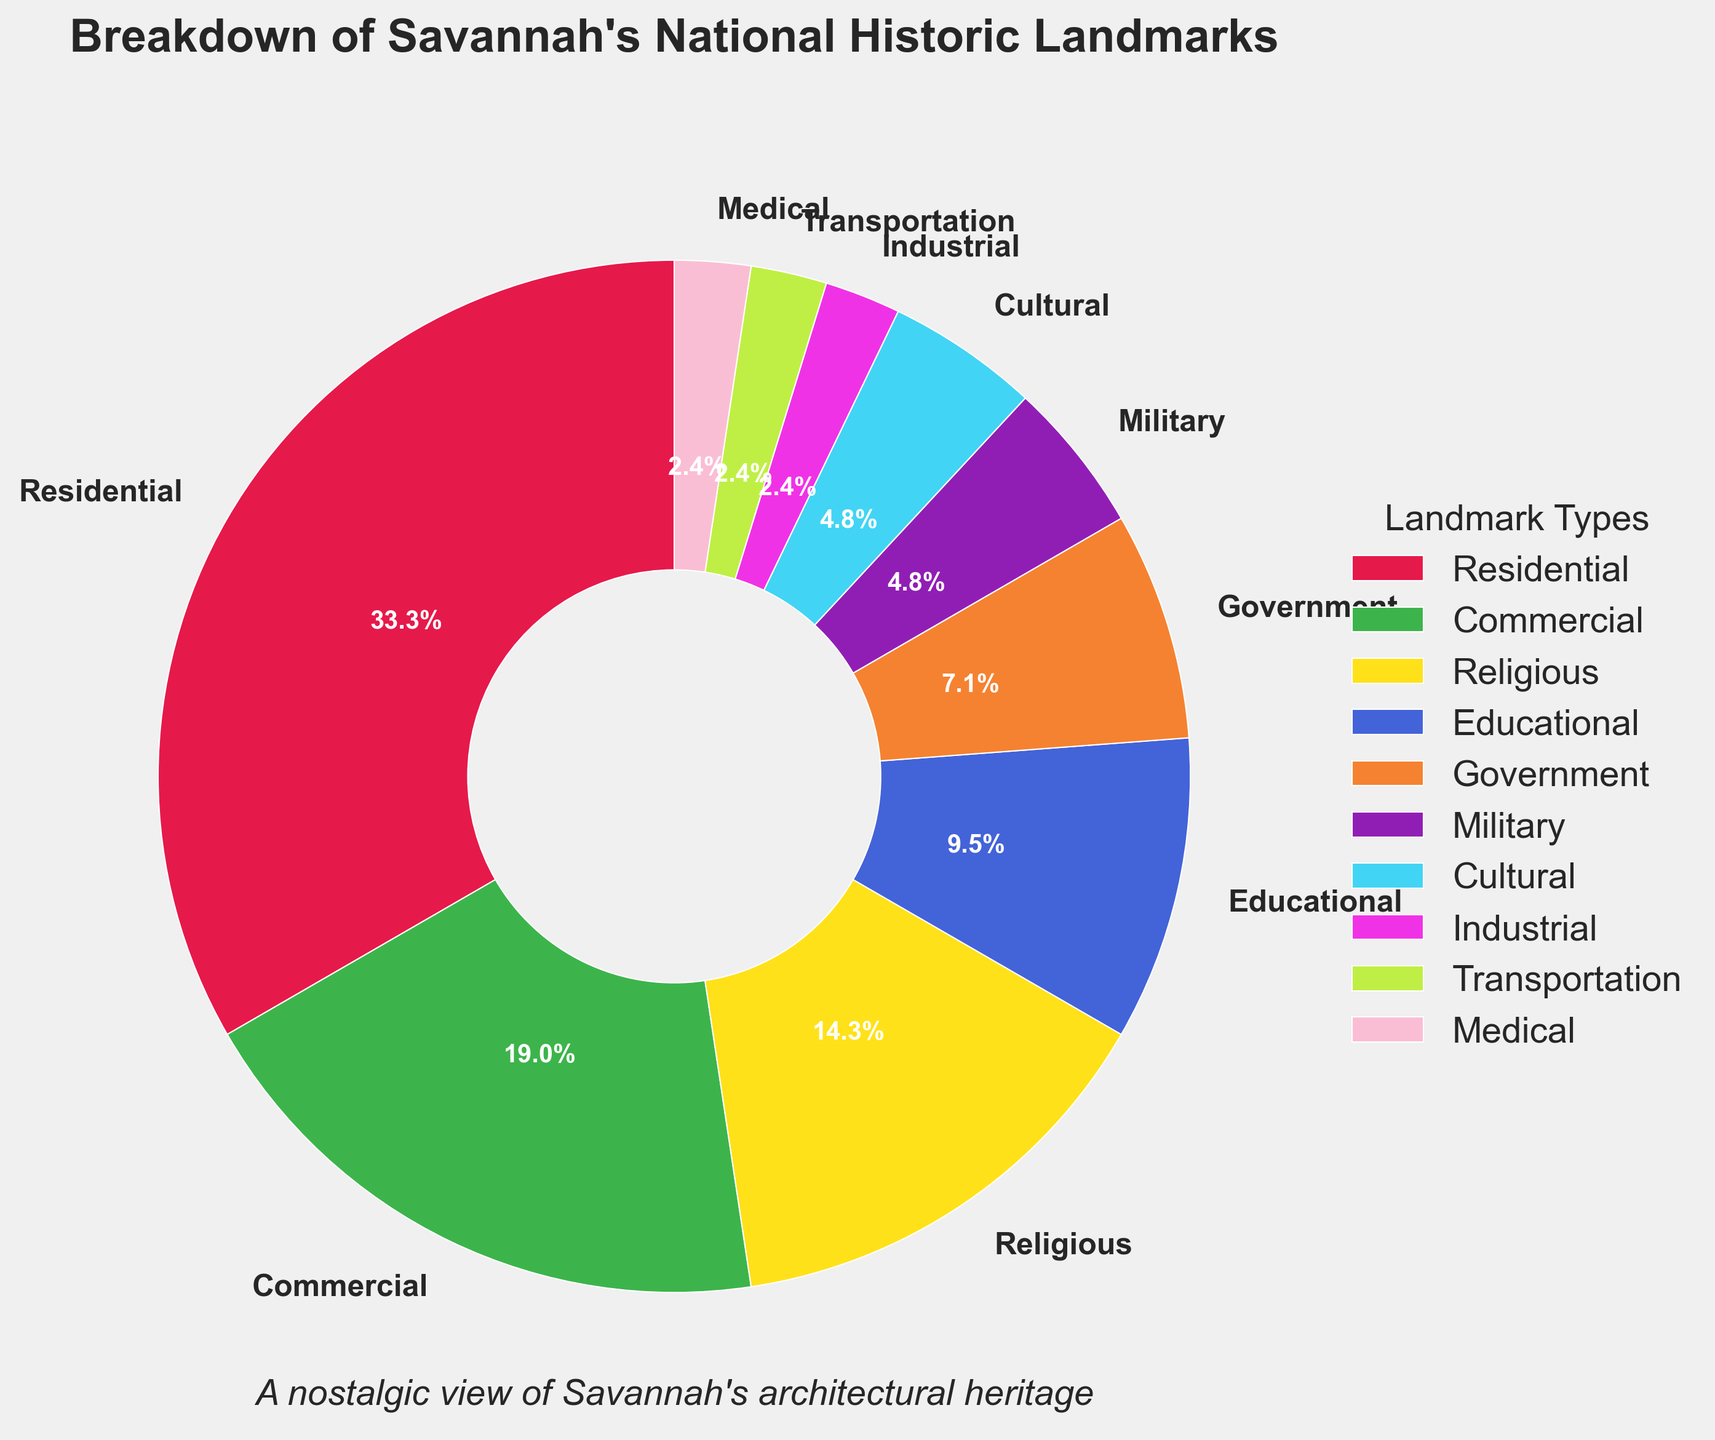Which type of landmark is the most common in Savannah's National Historic Landmarks? The pie chart shows the count of each landmark type. Residential landmarks have the largest segment in the chart.
Answer: Residential What percentage of Savannah’s National Historic Landmarks are industrial? The pie chart shows the percentage of each landmark type. The segment for industrial landmarks is labeled as 3.1%.
Answer: 3.1% How many types of landmarks have a count of 1? The pie chart lists the different types and their counts. There are three types (Industrial, Transportation, Medical) with a count of 1 each.
Answer: 3 What is the combined percentage of religious and educational landmarks? The segment for religious landmarks is labeled as 13.5%, and the educational ones are labeled as 9.0%. Adding these together: 13.5% + 9.0% = 22.5%.
Answer: 22.5% How do the counts of commercial landmarks compare to government landmarks? The pie chart shows the counts as 8 for commercial landmarks and 3 for government landmarks. 8 is greater than 3.
Answer: Commercial landmarks are more numerous Which type of landmark is represented by the green segment? The pie chart uses colors to differentiate types. The legend shows that the green segment corresponds to commercial landmarks.
Answer: Commercial What is the difference in count between residential and educational landmarks? The chart indicates 14 residential and 4 educational landmarks. Subtracting these: 14 - 4 = 10.
Answer: 10 Combined, do cultural and military landmarks outnumber commercial landmarks? The chart indicates 2 cultural and 2 military landmarks, which together are 4. The count for commercial landmarks is 8. 4 is less than 8.
Answer: No If you were to combine medical, transportation, and industrial landmarks, what would be their total count? The pie chart shows 1 medical, 1 transportation, and 1 industrial landmark. Adding these: 1 + 1 + 1 = 3.
Answer: 3 How many more residential landmarks are there than cultural landmarks? The chart indicates 14 residential and 2 cultural landmarks. Subtracting these: 14 - 2 = 12.
Answer: 12 